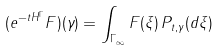Convert formula to latex. <formula><loc_0><loc_0><loc_500><loc_500>( e ^ { - t H ^ { \Gamma } } F ) ( \gamma ) = \int _ { \Gamma _ { \infty } } F ( \xi ) \, { P } _ { t , \gamma } ( d \xi )</formula> 